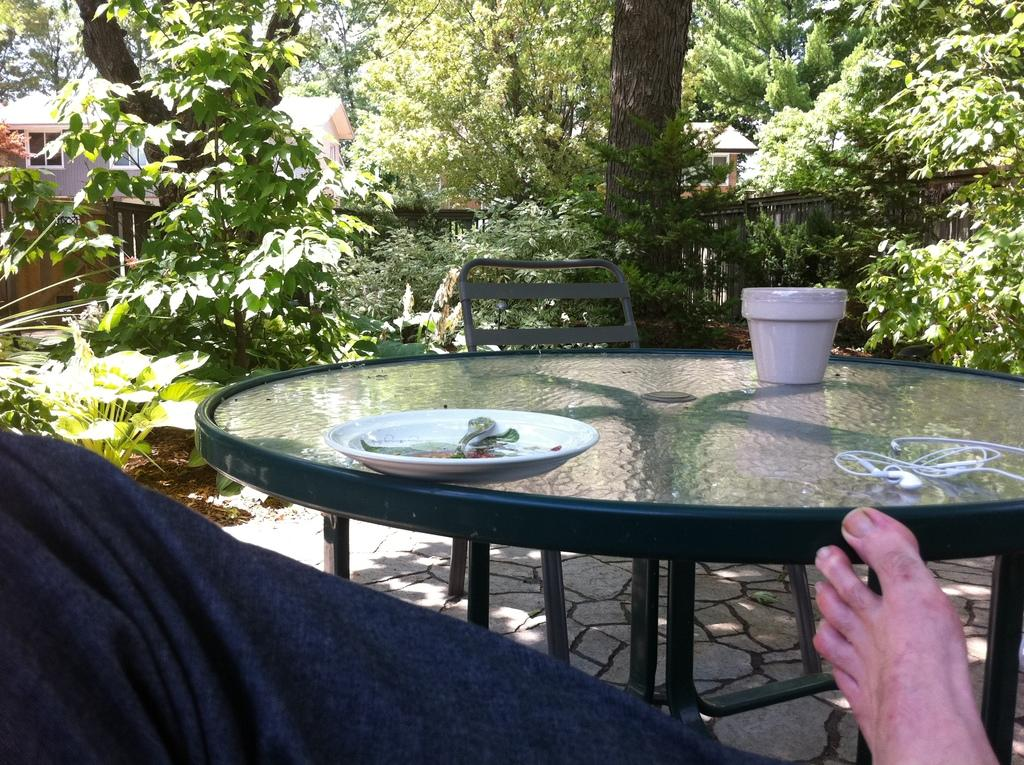What type of table is in the image? There is a glass table in the image. What is on top of the table? There is a plate and a pot on the table. What can be seen in the background of the image? Trees are visible in the image. Can you describe any part of a person in the image? A person's leg is present in the image. What type of sound can be heard coming from the stage in the image? There is no stage present in the image, so it is not possible to determine what sound might be heard. 